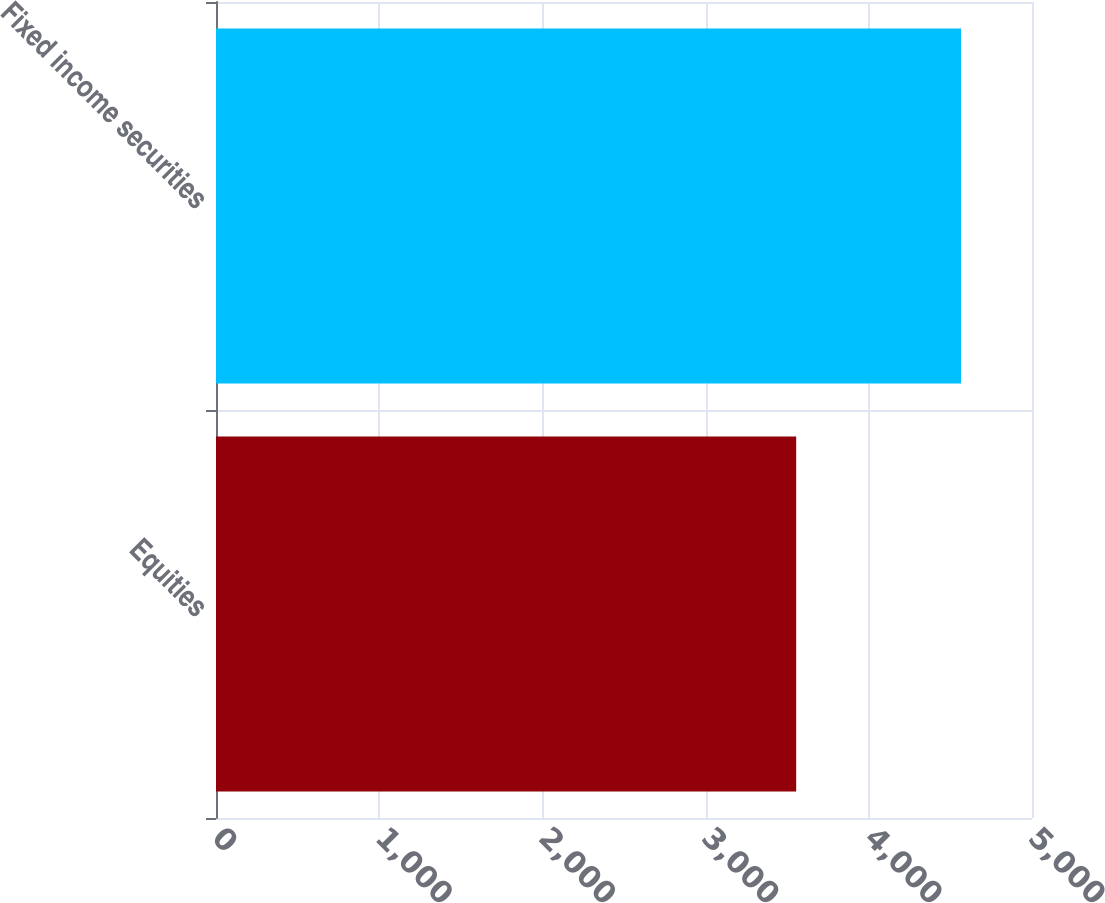Convert chart. <chart><loc_0><loc_0><loc_500><loc_500><bar_chart><fcel>Equities<fcel>Fixed income securities<nl><fcel>3555<fcel>4565<nl></chart> 